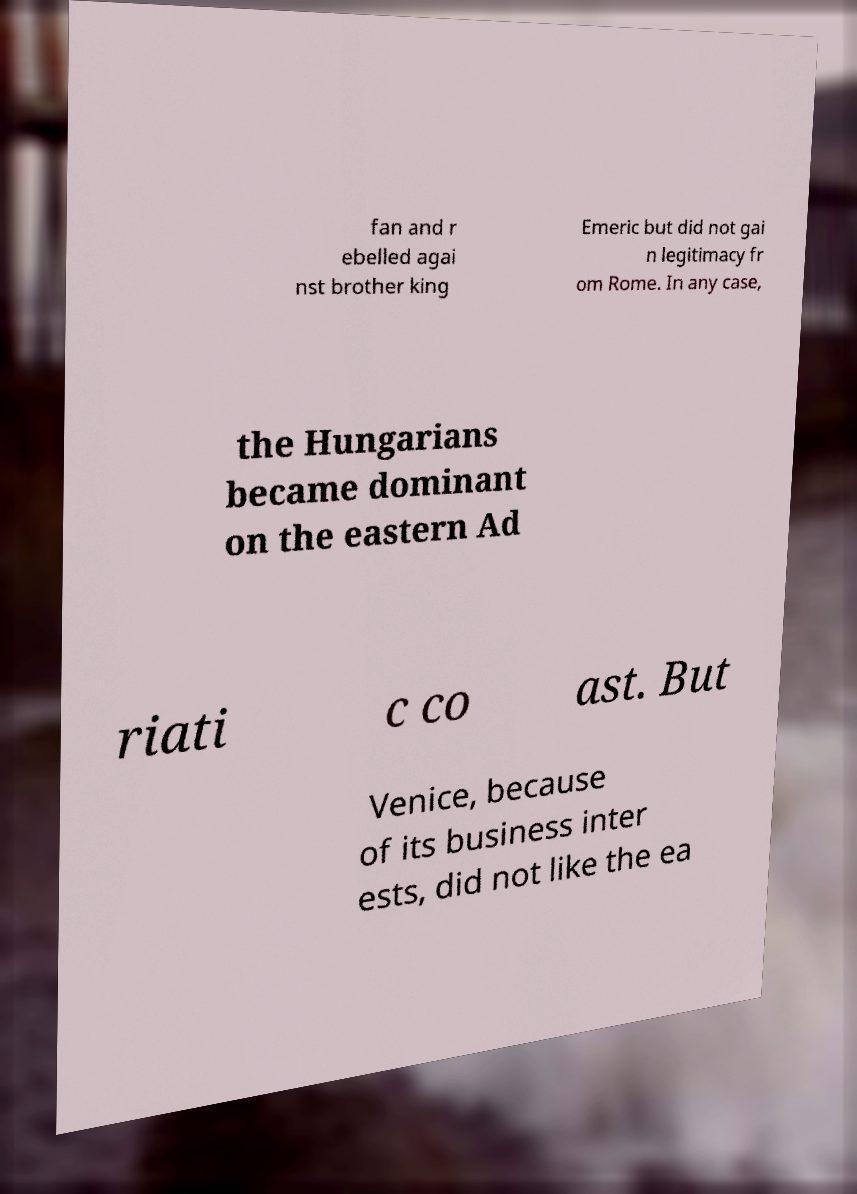Could you assist in decoding the text presented in this image and type it out clearly? fan and r ebelled agai nst brother king Emeric but did not gai n legitimacy fr om Rome. In any case, the Hungarians became dominant on the eastern Ad riati c co ast. But Venice, because of its business inter ests, did not like the ea 